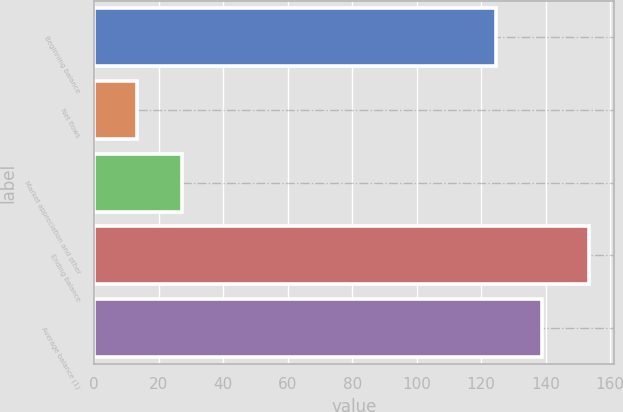Convert chart to OTSL. <chart><loc_0><loc_0><loc_500><loc_500><bar_chart><fcel>Beginning balance<fcel>Net flows<fcel>Market appreciation and other<fcel>Ending balance<fcel>Average balance (1)<nl><fcel>124.6<fcel>13.1<fcel>27.14<fcel>153.5<fcel>138.8<nl></chart> 